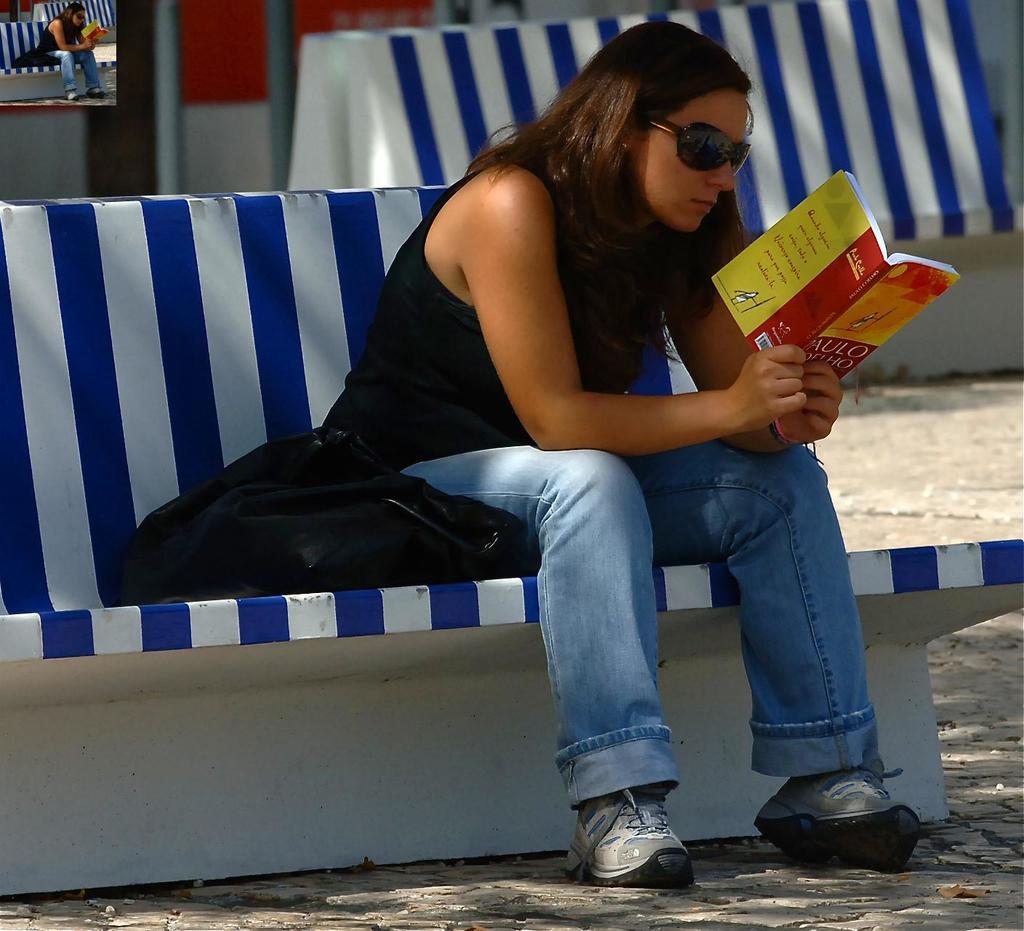Can you read the text on the back of the book?
Your answer should be compact. No. 